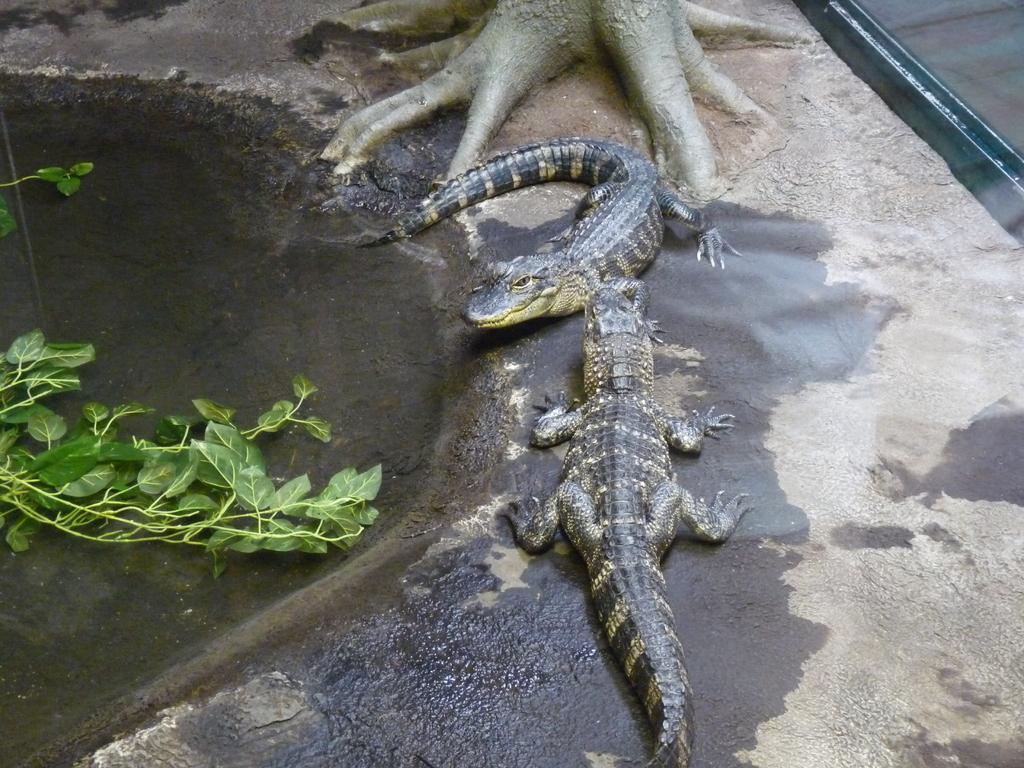Describe this image in one or two sentences. In front of the image there are crocodiles. There are roots of a tree. On the left side of the image there are leaves in the water. 